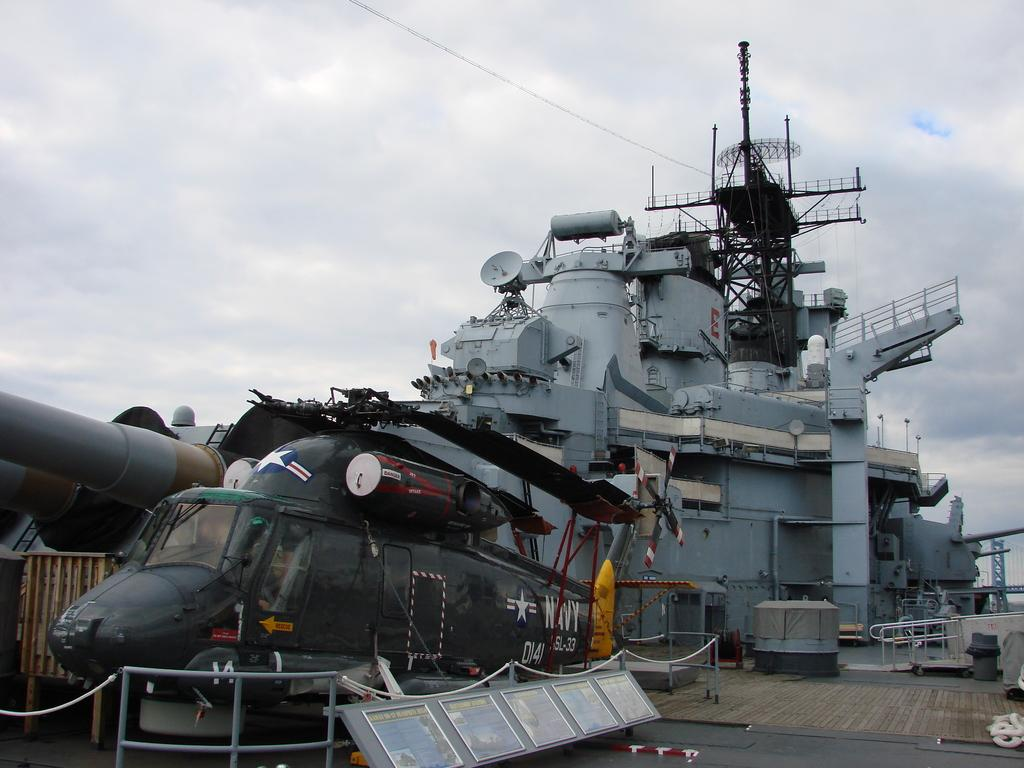What type of vehicle can be seen in the background of the image? There is a ship in the background of the image. What is located in front of the ship? There is a helicopter in front of the ship. What part of the natural environment is visible in the image? The sky is visible in the image. What can be observed in the sky? Clouds are present in the sky. What type of pump can be seen on the ship in the image? There is no pump visible on the ship in the image. How many hands are visible on the helicopter in the image? There are no hands visible on the helicopter in the image. 